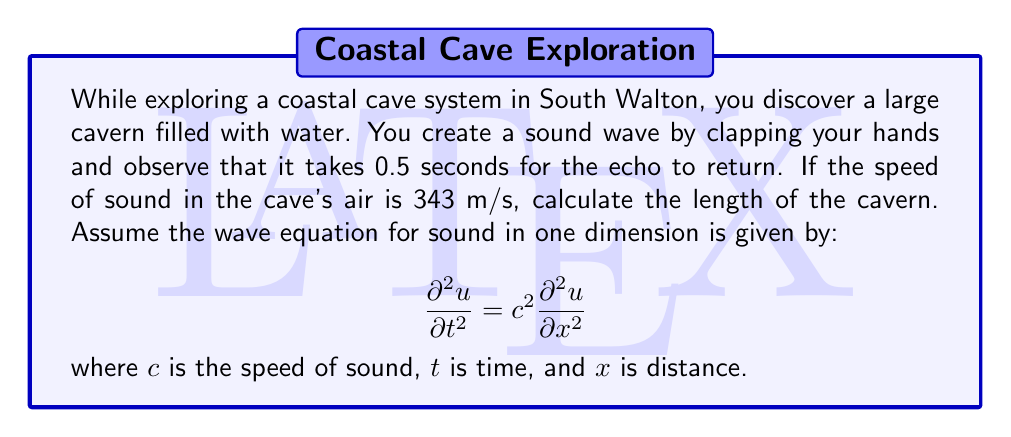Can you solve this math problem? To solve this problem, we'll follow these steps:

1) First, we need to understand that the time given (0.5 seconds) is the round-trip time for the sound wave. It travels to the end of the cavern and back.

2) The distance we're looking for is half of the total distance traveled by the sound wave.

3) We can use the basic equation for speed:

   $v = \frac{d}{t}$

   Where $v$ is velocity, $d$ is distance, and $t$ is time.

4) Rearranging this equation, we get:

   $d = v \times t$

5) The total distance traveled is:

   $d_{total} = 343 \text{ m/s} \times 0.5 \text{ s} = 171.5 \text{ m}$

6) The length of the cavern is half of this:

   $d_{cavern} = \frac{171.5 \text{ m}}{2} = 85.75 \text{ m}$

7) While we didn't explicitly use the wave equation in this calculation, it's worth noting that the speed of sound $c$ in the equation is what we used as our velocity (343 m/s). The wave equation describes how the sound propagates through the air in the cave.
Answer: 85.75 m 